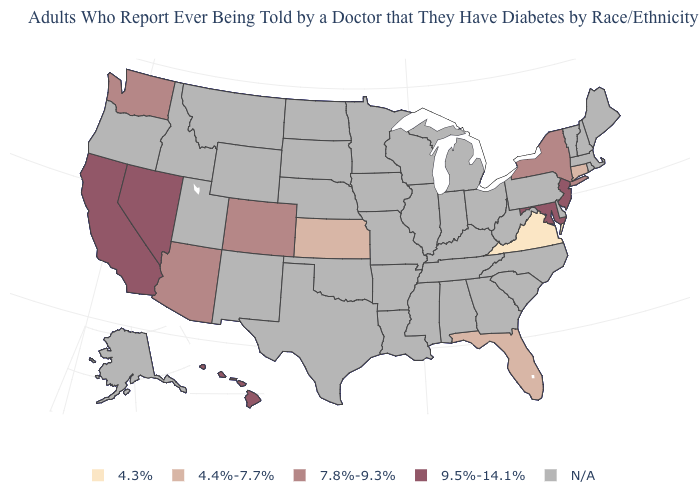Which states have the highest value in the USA?
Keep it brief. California, Hawaii, Maryland, Nevada, New Jersey. Among the states that border Connecticut , which have the lowest value?
Concise answer only. New York. How many symbols are there in the legend?
Write a very short answer. 5. Is the legend a continuous bar?
Answer briefly. No. Among the states that border Oregon , which have the highest value?
Keep it brief. California, Nevada. Does the map have missing data?
Be succinct. Yes. What is the value of Nevada?
Keep it brief. 9.5%-14.1%. What is the value of Wisconsin?
Give a very brief answer. N/A. Name the states that have a value in the range 4.3%?
Keep it brief. Virginia. Which states have the lowest value in the USA?
Concise answer only. Virginia. What is the value of Montana?
Concise answer only. N/A. What is the value of Wyoming?
Concise answer only. N/A. Name the states that have a value in the range 9.5%-14.1%?
Keep it brief. California, Hawaii, Maryland, Nevada, New Jersey. 